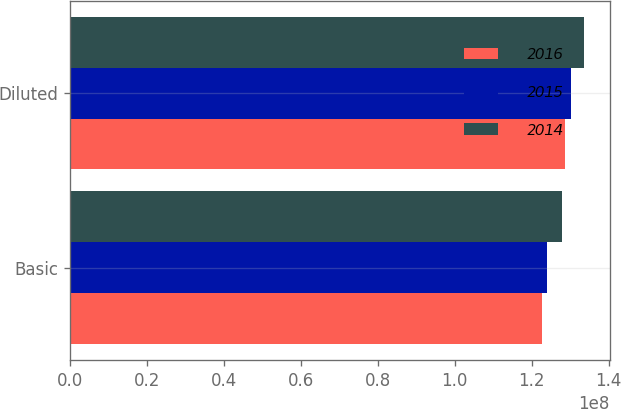Convert chart. <chart><loc_0><loc_0><loc_500><loc_500><stacked_bar_chart><ecel><fcel>Basic<fcel>Diluted<nl><fcel>2016<fcel>1.22651e+08<fcel>1.28553e+08<nl><fcel>2015<fcel>1.2404e+08<fcel>1.30189e+08<nl><fcel>2014<fcel>1.27874e+08<fcel>1.33652e+08<nl></chart> 